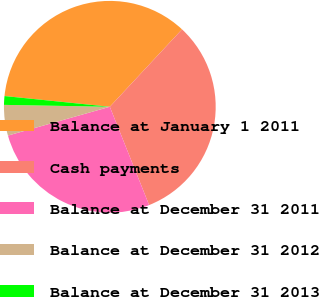Convert chart. <chart><loc_0><loc_0><loc_500><loc_500><pie_chart><fcel>Balance at January 1 2011<fcel>Cash payments<fcel>Balance at December 31 2011<fcel>Balance at December 31 2012<fcel>Balance at December 31 2013<nl><fcel>35.33%<fcel>32.0%<fcel>26.67%<fcel>4.67%<fcel>1.33%<nl></chart> 